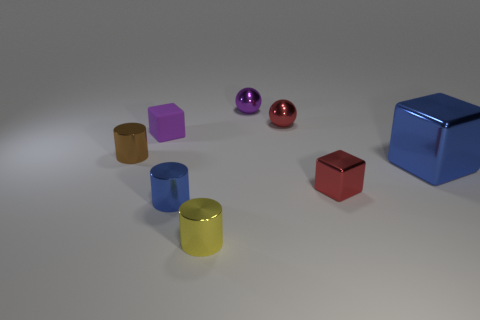There is a thing that is the same color as the tiny shiny cube; what material is it?
Your answer should be compact. Metal. The tiny thing that is left of the tiny blue shiny cylinder and in front of the small purple matte object has what shape?
Your answer should be very brief. Cylinder. Is there a blue shiny cylinder behind the blue shiny object on the left side of the purple object that is behind the red shiny sphere?
Make the answer very short. No. What number of other things are made of the same material as the small purple cube?
Make the answer very short. 0. What number of tiny blue metal cylinders are there?
Provide a succinct answer. 1. What number of things are either blue metallic cylinders or small red things that are on the left side of the red block?
Provide a short and direct response. 2. Is there any other thing that has the same shape as the yellow shiny object?
Your response must be concise. Yes. There is a red shiny object that is behind the brown thing; is its size the same as the tiny matte block?
Offer a terse response. Yes. How many rubber objects are either red cylinders or purple objects?
Ensure brevity in your answer.  1. What size is the purple object that is on the right side of the tiny rubber cube?
Give a very brief answer. Small. 